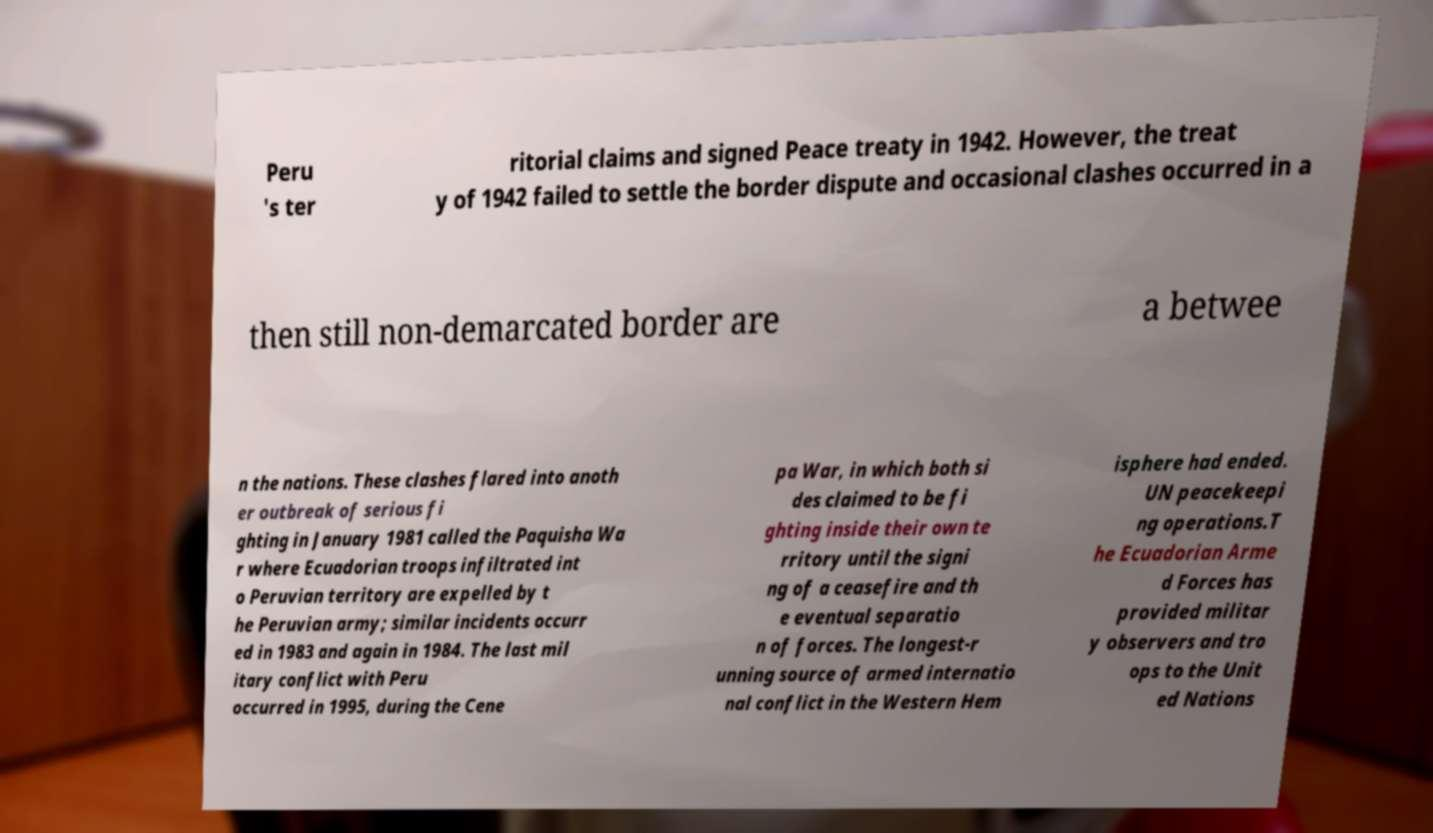I need the written content from this picture converted into text. Can you do that? Peru 's ter ritorial claims and signed Peace treaty in 1942. However, the treat y of 1942 failed to settle the border dispute and occasional clashes occurred in a then still non-demarcated border are a betwee n the nations. These clashes flared into anoth er outbreak of serious fi ghting in January 1981 called the Paquisha Wa r where Ecuadorian troops infiltrated int o Peruvian territory are expelled by t he Peruvian army; similar incidents occurr ed in 1983 and again in 1984. The last mil itary conflict with Peru occurred in 1995, during the Cene pa War, in which both si des claimed to be fi ghting inside their own te rritory until the signi ng of a ceasefire and th e eventual separatio n of forces. The longest-r unning source of armed internatio nal conflict in the Western Hem isphere had ended. UN peacekeepi ng operations.T he Ecuadorian Arme d Forces has provided militar y observers and tro ops to the Unit ed Nations 